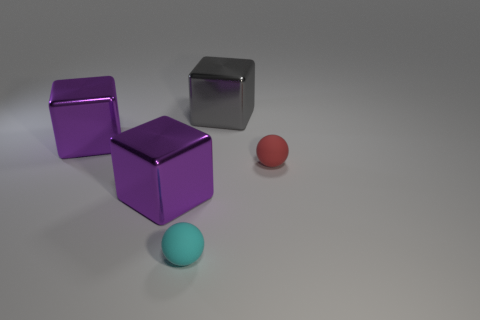Subtract all yellow cubes. Subtract all green balls. How many cubes are left? 3 Subtract all green cylinders. How many purple spheres are left? 0 Add 1 cyans. How many small reds exist? 0 Subtract all cyan matte objects. Subtract all balls. How many objects are left? 2 Add 1 tiny red spheres. How many tiny red spheres are left? 2 Add 3 small cyan rubber objects. How many small cyan rubber objects exist? 4 Add 2 big metallic blocks. How many objects exist? 7 Subtract all purple cubes. How many cubes are left? 1 Subtract all big gray cubes. How many cubes are left? 2 Subtract 1 gray cubes. How many objects are left? 4 